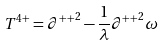Convert formula to latex. <formula><loc_0><loc_0><loc_500><loc_500>T ^ { 4 + } = { \partial ^ { + + } } ^ { 2 } - \frac { 1 } { \lambda } { \partial ^ { + + } } ^ { 2 } \omega</formula> 